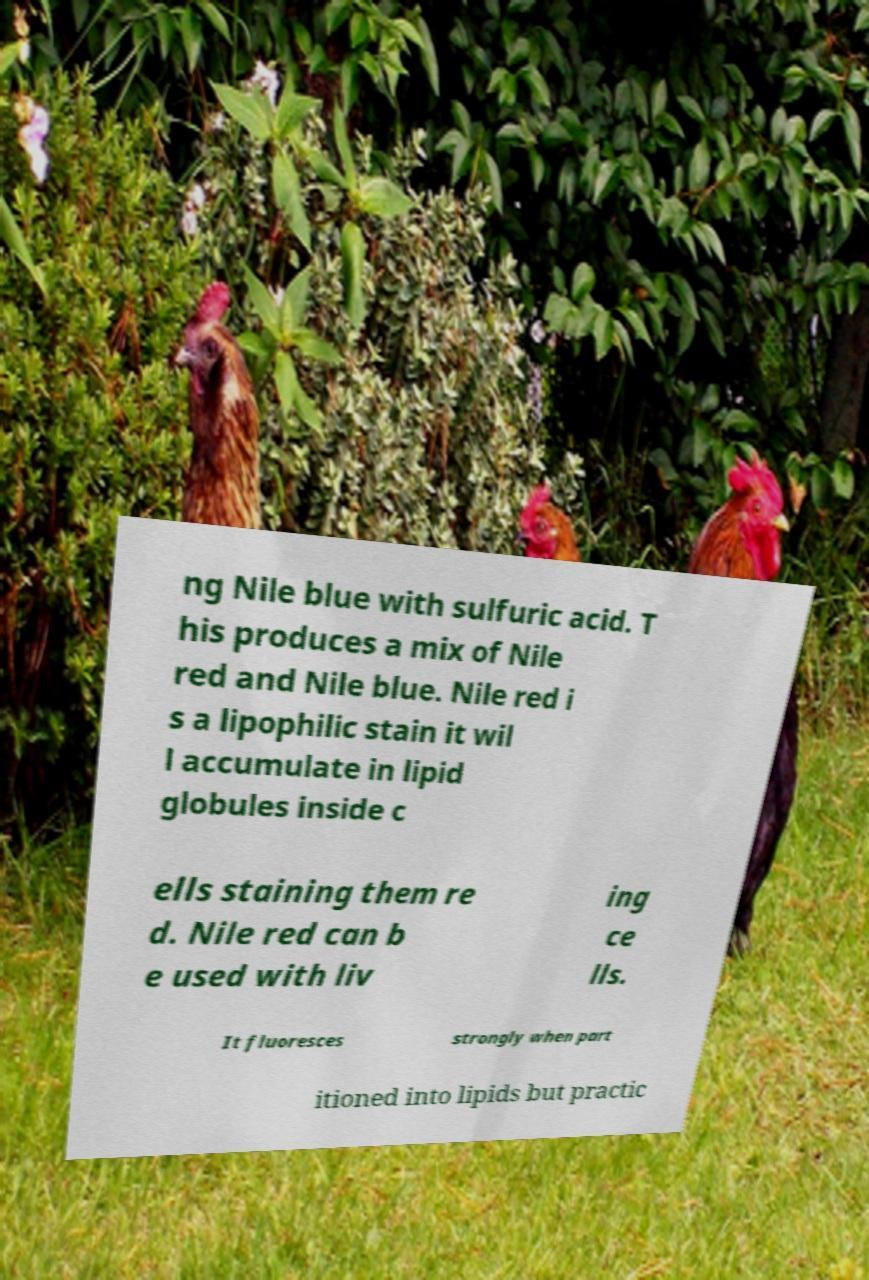Can you accurately transcribe the text from the provided image for me? ng Nile blue with sulfuric acid. T his produces a mix of Nile red and Nile blue. Nile red i s a lipophilic stain it wil l accumulate in lipid globules inside c ells staining them re d. Nile red can b e used with liv ing ce lls. It fluoresces strongly when part itioned into lipids but practic 